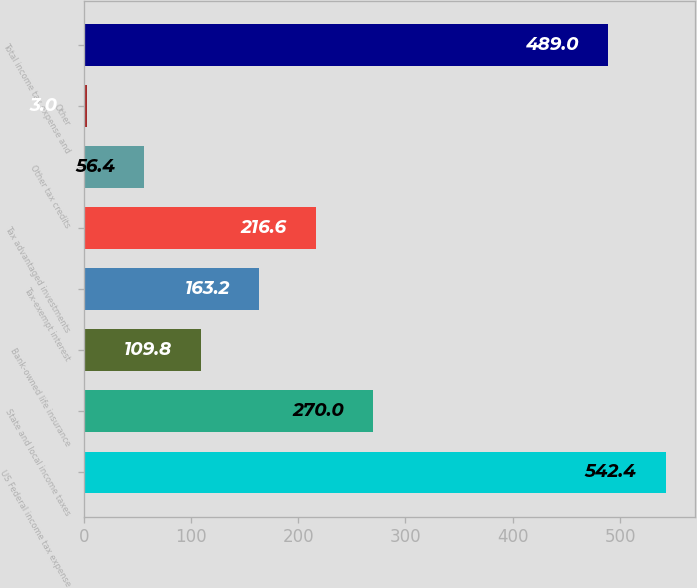Convert chart to OTSL. <chart><loc_0><loc_0><loc_500><loc_500><bar_chart><fcel>US Federal income tax expense<fcel>State and local income taxes<fcel>Bank-owned life insurance<fcel>Tax-exempt interest<fcel>Tax advantaged investments<fcel>Other tax credits<fcel>Other<fcel>Total income tax expense and<nl><fcel>542.4<fcel>270<fcel>109.8<fcel>163.2<fcel>216.6<fcel>56.4<fcel>3<fcel>489<nl></chart> 